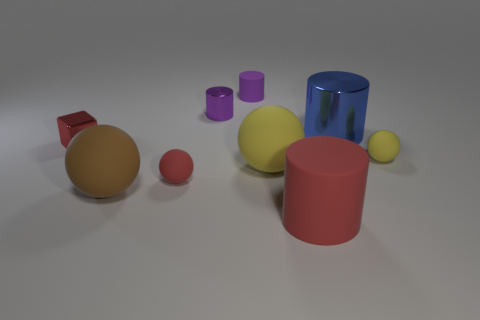What materials do these objects appear to be made of? The objects in the image seem to be made of various materials: the red and pink cylinders and the orange sphere could be plastic or rubber due to their matte surfaces, while the blue cylinder has a reflective surface suggesting it might be made of glass or polished metal. 